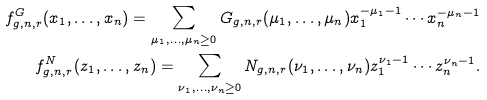Convert formula to latex. <formula><loc_0><loc_0><loc_500><loc_500>f _ { g , n , r } ^ { G } ( x _ { 1 } , \dots , x _ { n } ) = \sum _ { \mu _ { 1 } , \dots , \mu _ { n } \geq 0 } G _ { g , n , r } ( \mu _ { 1 } , \dots , \mu _ { n } ) x _ { 1 } ^ { - \mu _ { 1 } - 1 } \cdots x _ { n } ^ { - \mu _ { n } - 1 } \\ f _ { g , n , r } ^ { N } ( z _ { 1 } , \dots , z _ { n } ) = \sum _ { \nu _ { 1 } , \dots , \nu _ { n } \geq 0 } N _ { g , n , r } ( \nu _ { 1 } , \dots , \nu _ { n } ) z _ { 1 } ^ { \nu _ { 1 } - 1 } \cdots z _ { n } ^ { \nu _ { n } - 1 } .</formula> 